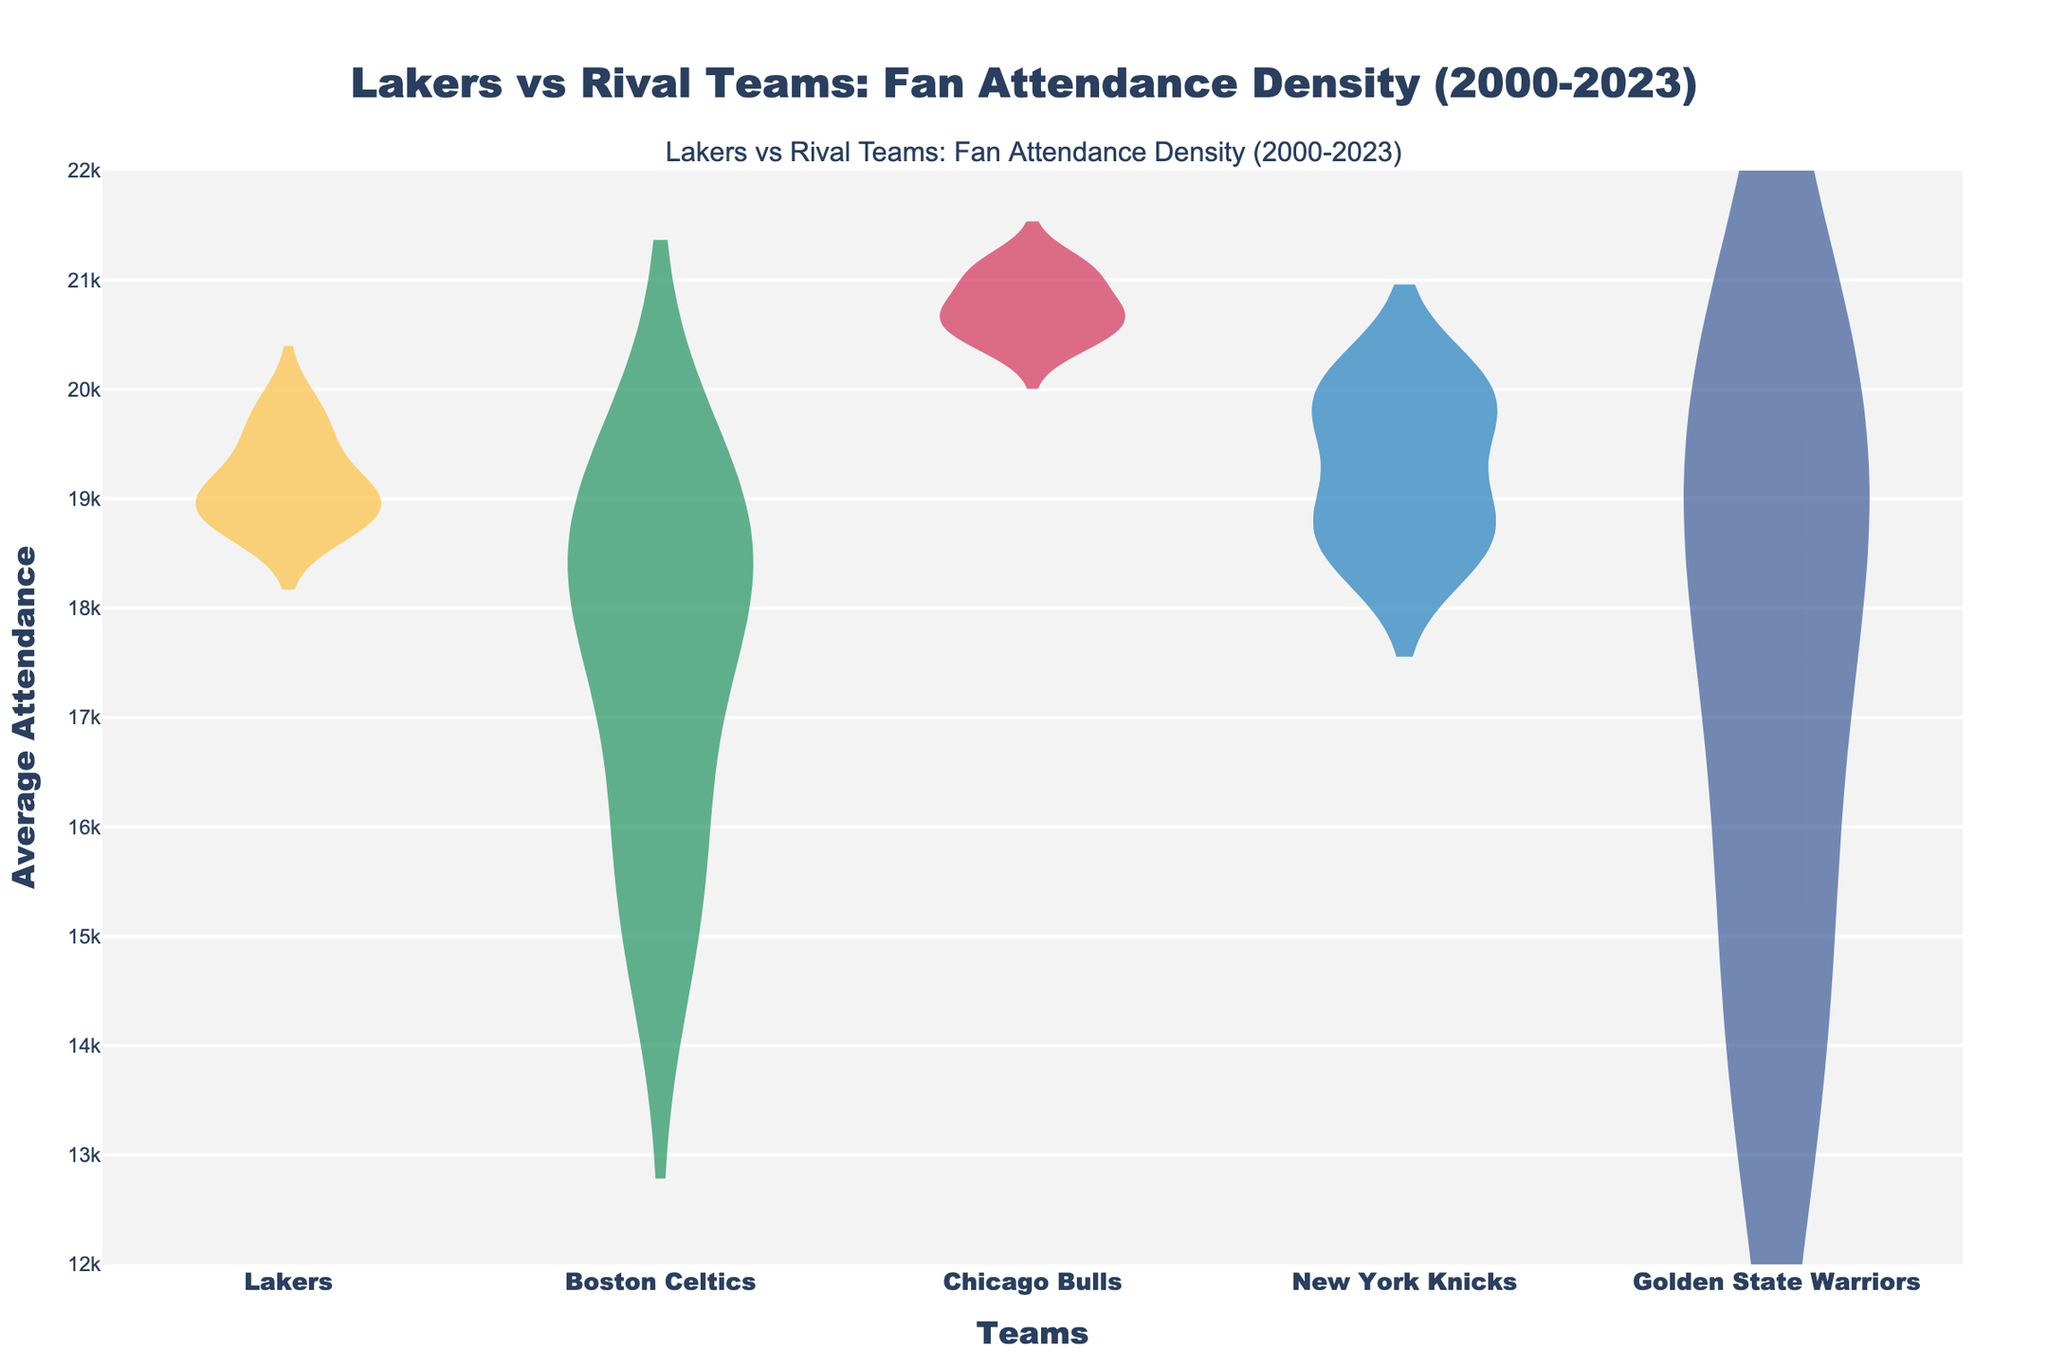Which team has the highest average attendance between 2000 and 2023? By looking at the density plot, we can identify the team with the highest average attendance by observing the violin plot with the highest upper limit on the y-axis.
Answer: Chicago Bulls Which team's attendance shows the highest variability? To determine which team's attendance has the highest variability, look for the violin plot with the widest spread on the y-axis. The team with the broadest range of attendance values indicates the highest variability.
Answer: Chicago Bulls How does the Lakers' average attendance in 2023 compare to the Celtics' average attendance in 2023? By comparing the y-axis values for the Lakers and Celtics in 2023, we can see that the Lakers' average attendance is slightly higher than the Celtics'.
Answer: Lakers' attendance is higher What is the approximate range of the Lakers' average attendance? Look at the vertical extent of the Lakers' violin plot on the y-axis to find the minimum and maximum values.
Answer: Approx. 18767 to 19800 Which team's density plot shows the most consistent fan attendance across the years? The team with the narrowest violin plot (smallest range) on the y-axis demonstrates the most consistent fan attendance over the years.
Answer: Lakers Between 2005 and 2023, which team experienced a visible increase in average attendance? Look at the progression of the density plots over the years for each team to identify a rising trend. Specifically, observe changes in the y-axis placement for each team.
Answer: Boston Celtics How does the median attendance of the Lakers compare to that of the Knicks? Identify the horizontal line inside each violin plot that denotes the median and compare the positions. The Lakers' median should be higher than the Knicks' if the line is higher on the y-axis.
Answer: Lakers' median is higher Did the Golden State Warriors' average attendance surpass the Lakers' average attendance at any point within 2000-2023? Check the y-axis range for the Golden State Warriors' violin plot to see if there are segments where it extends higher than the Lakers' plot.
Answer: No How does the variability of the Knicks' attendance compare to that of the Bulls? Compare the spread of the violin plots for both teams; the team with the wider spread in the y-axis range indicates higher variability.
Answer: Bulls have higher variability What is the trend in average attendance for the Lakers from 2000 to 2023? Observe the y-axis values of the Lakers' violin plots over the years to determine if there is an increasing, decreasing, or stable trend.
Answer: Increasing trend 